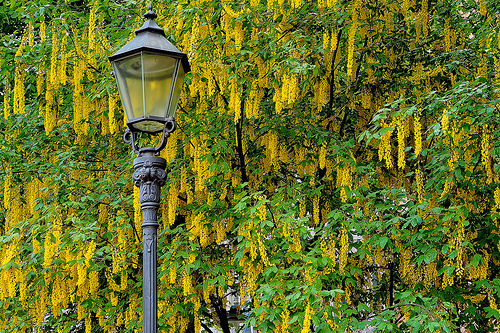<image>
Is there a lamp on the tree? No. The lamp is not positioned on the tree. They may be near each other, but the lamp is not supported by or resting on top of the tree. Is there a trees in front of the lamppost? Yes. The trees is positioned in front of the lamppost, appearing closer to the camera viewpoint. 